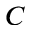<formula> <loc_0><loc_0><loc_500><loc_500>C</formula> 